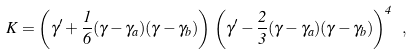<formula> <loc_0><loc_0><loc_500><loc_500>K = \left ( \gamma ^ { \prime } + \frac { 1 } { 6 } ( \gamma - \gamma _ { a } ) ( \gamma - \gamma _ { b } ) \right ) \, \left ( \gamma ^ { \prime } - \frac { 2 } { 3 } ( \gamma - \gamma _ { a } ) ( \gamma - \gamma _ { b } ) \right ) ^ { 4 } \ ,</formula> 